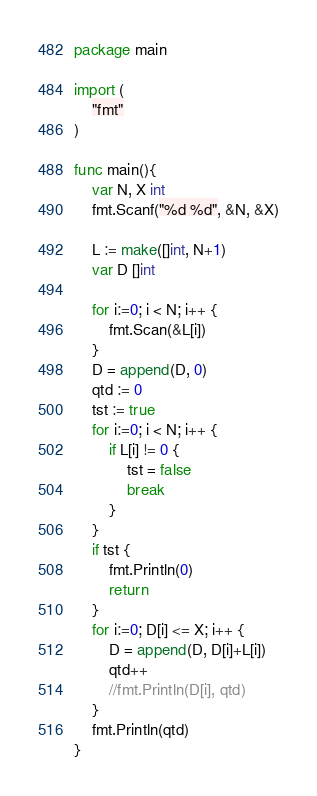Convert code to text. <code><loc_0><loc_0><loc_500><loc_500><_Go_>package main

import (
	"fmt"
)

func main(){
	var N, X int
	fmt.Scanf("%d %d", &N, &X)

	L := make([]int, N+1)
	var D []int
	
	for i:=0; i < N; i++ {
		fmt.Scan(&L[i])
	}
	D = append(D, 0)
	qtd := 0
	tst := true
	for i:=0; i < N; i++ {
		if L[i] != 0 {
			tst = false
			break
		}
	}
	if tst {
		fmt.Println(0)
		return
	}
	for i:=0; D[i] <= X; i++ {
		D = append(D, D[i]+L[i])
		qtd++
		//fmt.Println(D[i], qtd)
	}
	fmt.Println(qtd)
}</code> 